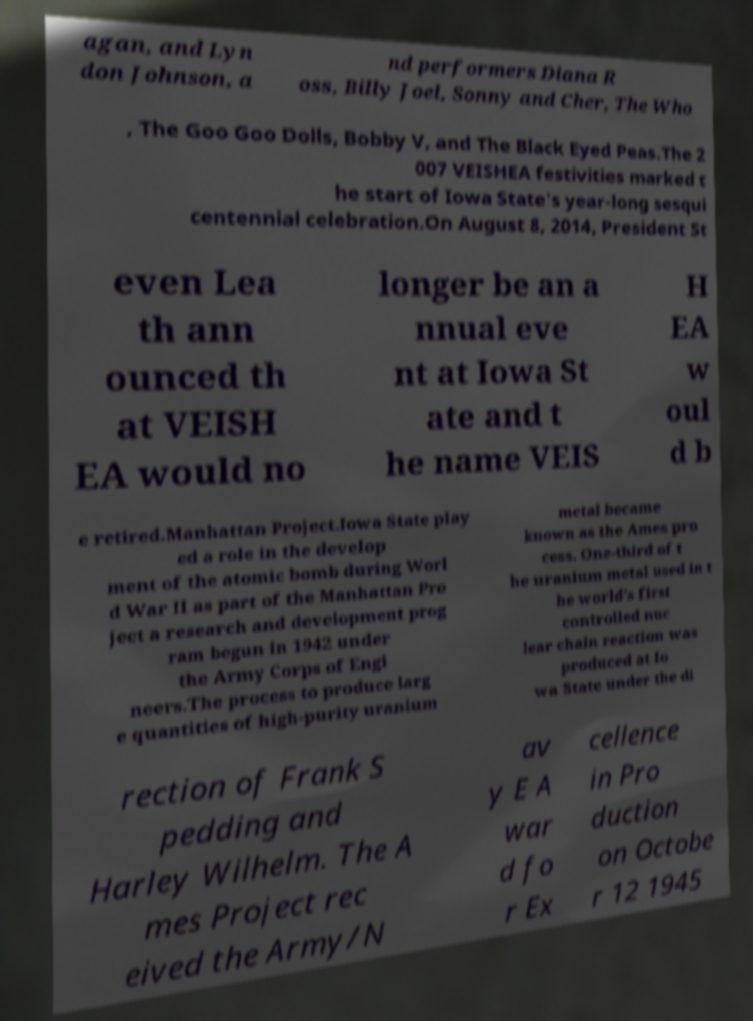I need the written content from this picture converted into text. Can you do that? agan, and Lyn don Johnson, a nd performers Diana R oss, Billy Joel, Sonny and Cher, The Who , The Goo Goo Dolls, Bobby V, and The Black Eyed Peas.The 2 007 VEISHEA festivities marked t he start of Iowa State's year-long sesqui centennial celebration.On August 8, 2014, President St even Lea th ann ounced th at VEISH EA would no longer be an a nnual eve nt at Iowa St ate and t he name VEIS H EA w oul d b e retired.Manhattan Project.Iowa State play ed a role in the develop ment of the atomic bomb during Worl d War II as part of the Manhattan Pro ject a research and development prog ram begun in 1942 under the Army Corps of Engi neers.The process to produce larg e quantities of high-purity uranium metal became known as the Ames pro cess. One-third of t he uranium metal used in t he world's first controlled nuc lear chain reaction was produced at Io wa State under the di rection of Frank S pedding and Harley Wilhelm. The A mes Project rec eived the Army/N av y E A war d fo r Ex cellence in Pro duction on Octobe r 12 1945 